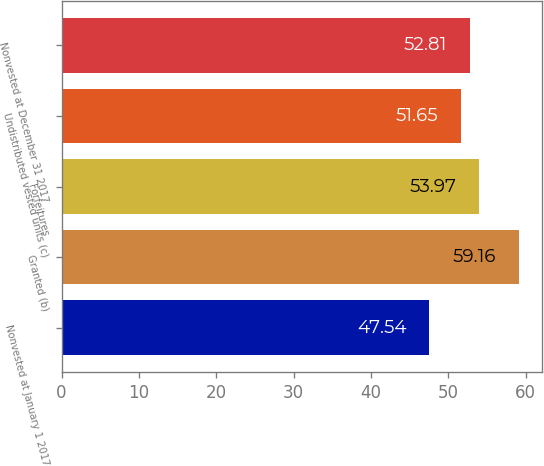Convert chart to OTSL. <chart><loc_0><loc_0><loc_500><loc_500><bar_chart><fcel>Nonvested at January 1 2017<fcel>Granted (b)<fcel>Forfeitures<fcel>Undistributed vested units (c)<fcel>Nonvested at December 31 2017<nl><fcel>47.54<fcel>59.16<fcel>53.97<fcel>51.65<fcel>52.81<nl></chart> 